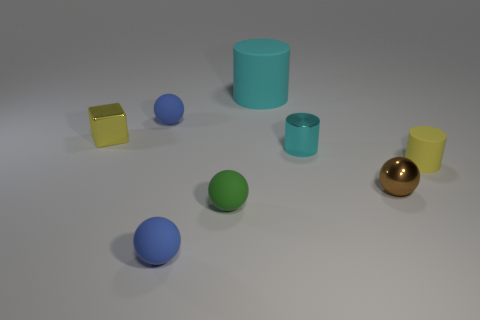There is a small sphere behind the yellow object left of the large thing; what color is it? The small sphere situated behind the yellow cube, which is to the left of the large blue cylinder, is green. 